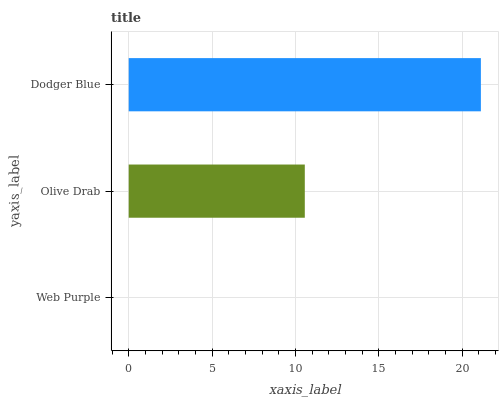Is Web Purple the minimum?
Answer yes or no. Yes. Is Dodger Blue the maximum?
Answer yes or no. Yes. Is Olive Drab the minimum?
Answer yes or no. No. Is Olive Drab the maximum?
Answer yes or no. No. Is Olive Drab greater than Web Purple?
Answer yes or no. Yes. Is Web Purple less than Olive Drab?
Answer yes or no. Yes. Is Web Purple greater than Olive Drab?
Answer yes or no. No. Is Olive Drab less than Web Purple?
Answer yes or no. No. Is Olive Drab the high median?
Answer yes or no. Yes. Is Olive Drab the low median?
Answer yes or no. Yes. Is Dodger Blue the high median?
Answer yes or no. No. Is Web Purple the low median?
Answer yes or no. No. 